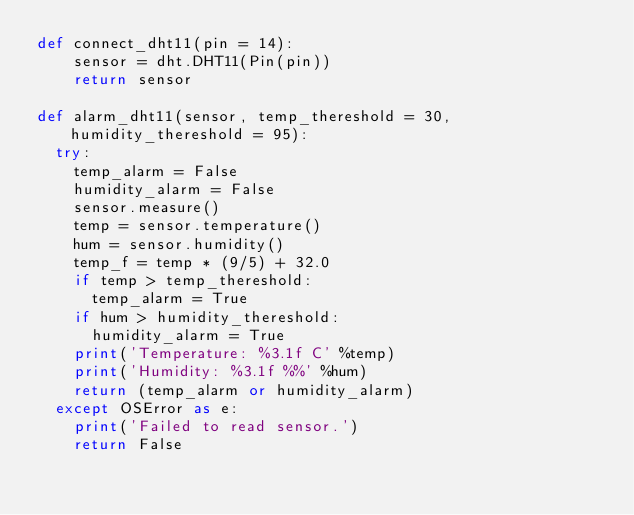<code> <loc_0><loc_0><loc_500><loc_500><_Python_>def connect_dht11(pin = 14):
    sensor = dht.DHT11(Pin(pin))
    return sensor

def alarm_dht11(sensor, temp_thereshold = 30, humidity_thereshold = 95):
  try:
    temp_alarm = False
    humidity_alarm = False
    sensor.measure()
    temp = sensor.temperature()
    hum = sensor.humidity()
    temp_f = temp * (9/5) + 32.0
    if temp > temp_thereshold:
      temp_alarm = True
    if hum > humidity_thereshold:
      humidity_alarm = True
    print('Temperature: %3.1f C' %temp)
    print('Humidity: %3.1f %%' %hum)
    return (temp_alarm or humidity_alarm)
  except OSError as e:
    print('Failed to read sensor.')
    return False</code> 